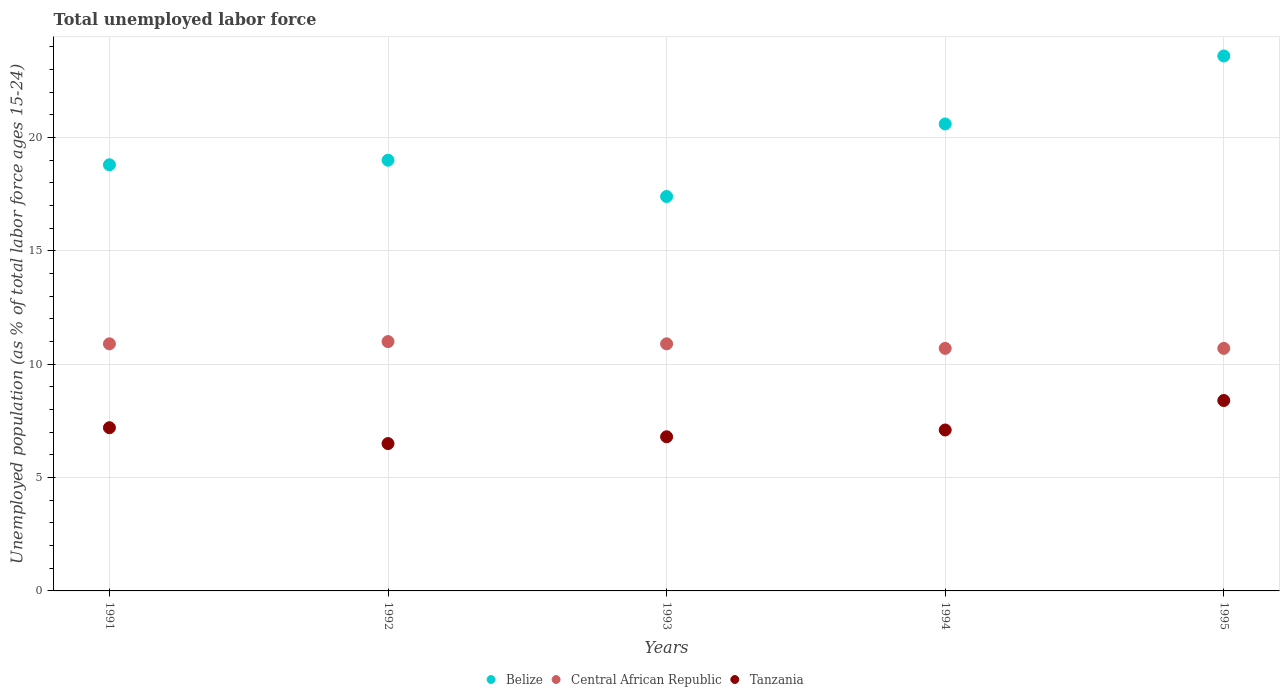Is the number of dotlines equal to the number of legend labels?
Provide a short and direct response. Yes. What is the percentage of unemployed population in in Tanzania in 1994?
Offer a terse response. 7.1. What is the total percentage of unemployed population in in Central African Republic in the graph?
Provide a short and direct response. 54.2. What is the difference between the percentage of unemployed population in in Central African Republic in 1991 and that in 1993?
Your answer should be compact. 0. What is the difference between the percentage of unemployed population in in Belize in 1993 and the percentage of unemployed population in in Central African Republic in 1995?
Provide a short and direct response. 6.7. What is the average percentage of unemployed population in in Tanzania per year?
Provide a succinct answer. 7.2. In the year 1993, what is the difference between the percentage of unemployed population in in Central African Republic and percentage of unemployed population in in Tanzania?
Provide a short and direct response. 4.1. What is the ratio of the percentage of unemployed population in in Belize in 1992 to that in 1995?
Provide a short and direct response. 0.81. Is the difference between the percentage of unemployed population in in Central African Republic in 1991 and 1993 greater than the difference between the percentage of unemployed population in in Tanzania in 1991 and 1993?
Make the answer very short. No. What is the difference between the highest and the second highest percentage of unemployed population in in Tanzania?
Your response must be concise. 1.2. What is the difference between the highest and the lowest percentage of unemployed population in in Central African Republic?
Make the answer very short. 0.3. Does the percentage of unemployed population in in Belize monotonically increase over the years?
Your answer should be compact. No. Is the percentage of unemployed population in in Tanzania strictly less than the percentage of unemployed population in in Central African Republic over the years?
Your response must be concise. Yes. What is the difference between two consecutive major ticks on the Y-axis?
Provide a short and direct response. 5. Are the values on the major ticks of Y-axis written in scientific E-notation?
Offer a terse response. No. Does the graph contain grids?
Your answer should be very brief. Yes. Where does the legend appear in the graph?
Your answer should be compact. Bottom center. How many legend labels are there?
Offer a terse response. 3. How are the legend labels stacked?
Give a very brief answer. Horizontal. What is the title of the graph?
Make the answer very short. Total unemployed labor force. Does "Northern Mariana Islands" appear as one of the legend labels in the graph?
Provide a succinct answer. No. What is the label or title of the X-axis?
Offer a very short reply. Years. What is the label or title of the Y-axis?
Offer a terse response. Unemployed population (as % of total labor force ages 15-24). What is the Unemployed population (as % of total labor force ages 15-24) in Belize in 1991?
Your response must be concise. 18.8. What is the Unemployed population (as % of total labor force ages 15-24) in Central African Republic in 1991?
Ensure brevity in your answer.  10.9. What is the Unemployed population (as % of total labor force ages 15-24) of Tanzania in 1991?
Your response must be concise. 7.2. What is the Unemployed population (as % of total labor force ages 15-24) in Belize in 1993?
Ensure brevity in your answer.  17.4. What is the Unemployed population (as % of total labor force ages 15-24) of Central African Republic in 1993?
Your response must be concise. 10.9. What is the Unemployed population (as % of total labor force ages 15-24) of Tanzania in 1993?
Your answer should be very brief. 6.8. What is the Unemployed population (as % of total labor force ages 15-24) in Belize in 1994?
Provide a succinct answer. 20.6. What is the Unemployed population (as % of total labor force ages 15-24) of Central African Republic in 1994?
Your answer should be compact. 10.7. What is the Unemployed population (as % of total labor force ages 15-24) of Tanzania in 1994?
Offer a terse response. 7.1. What is the Unemployed population (as % of total labor force ages 15-24) of Belize in 1995?
Provide a short and direct response. 23.6. What is the Unemployed population (as % of total labor force ages 15-24) of Central African Republic in 1995?
Keep it short and to the point. 10.7. What is the Unemployed population (as % of total labor force ages 15-24) in Tanzania in 1995?
Ensure brevity in your answer.  8.4. Across all years, what is the maximum Unemployed population (as % of total labor force ages 15-24) in Belize?
Your answer should be compact. 23.6. Across all years, what is the maximum Unemployed population (as % of total labor force ages 15-24) in Tanzania?
Make the answer very short. 8.4. Across all years, what is the minimum Unemployed population (as % of total labor force ages 15-24) of Belize?
Ensure brevity in your answer.  17.4. Across all years, what is the minimum Unemployed population (as % of total labor force ages 15-24) of Central African Republic?
Your answer should be very brief. 10.7. Across all years, what is the minimum Unemployed population (as % of total labor force ages 15-24) of Tanzania?
Your answer should be compact. 6.5. What is the total Unemployed population (as % of total labor force ages 15-24) of Belize in the graph?
Provide a short and direct response. 99.4. What is the total Unemployed population (as % of total labor force ages 15-24) of Central African Republic in the graph?
Ensure brevity in your answer.  54.2. What is the total Unemployed population (as % of total labor force ages 15-24) of Tanzania in the graph?
Your answer should be very brief. 36. What is the difference between the Unemployed population (as % of total labor force ages 15-24) in Belize in 1991 and that in 1992?
Your answer should be compact. -0.2. What is the difference between the Unemployed population (as % of total labor force ages 15-24) in Central African Republic in 1991 and that in 1993?
Provide a succinct answer. 0. What is the difference between the Unemployed population (as % of total labor force ages 15-24) in Tanzania in 1991 and that in 1994?
Offer a very short reply. 0.1. What is the difference between the Unemployed population (as % of total labor force ages 15-24) of Central African Republic in 1991 and that in 1995?
Your response must be concise. 0.2. What is the difference between the Unemployed population (as % of total labor force ages 15-24) in Tanzania in 1991 and that in 1995?
Offer a terse response. -1.2. What is the difference between the Unemployed population (as % of total labor force ages 15-24) in Central African Republic in 1992 and that in 1993?
Provide a succinct answer. 0.1. What is the difference between the Unemployed population (as % of total labor force ages 15-24) of Tanzania in 1992 and that in 1993?
Provide a succinct answer. -0.3. What is the difference between the Unemployed population (as % of total labor force ages 15-24) of Belize in 1992 and that in 1994?
Keep it short and to the point. -1.6. What is the difference between the Unemployed population (as % of total labor force ages 15-24) in Central African Republic in 1992 and that in 1994?
Give a very brief answer. 0.3. What is the difference between the Unemployed population (as % of total labor force ages 15-24) of Tanzania in 1992 and that in 1994?
Make the answer very short. -0.6. What is the difference between the Unemployed population (as % of total labor force ages 15-24) in Central African Republic in 1992 and that in 1995?
Offer a terse response. 0.3. What is the difference between the Unemployed population (as % of total labor force ages 15-24) in Tanzania in 1992 and that in 1995?
Provide a succinct answer. -1.9. What is the difference between the Unemployed population (as % of total labor force ages 15-24) of Belize in 1993 and that in 1994?
Your answer should be very brief. -3.2. What is the difference between the Unemployed population (as % of total labor force ages 15-24) in Central African Republic in 1993 and that in 1994?
Ensure brevity in your answer.  0.2. What is the difference between the Unemployed population (as % of total labor force ages 15-24) of Tanzania in 1993 and that in 1994?
Give a very brief answer. -0.3. What is the difference between the Unemployed population (as % of total labor force ages 15-24) in Central African Republic in 1993 and that in 1995?
Offer a very short reply. 0.2. What is the difference between the Unemployed population (as % of total labor force ages 15-24) in Tanzania in 1993 and that in 1995?
Your answer should be very brief. -1.6. What is the difference between the Unemployed population (as % of total labor force ages 15-24) in Central African Republic in 1994 and that in 1995?
Your answer should be very brief. 0. What is the difference between the Unemployed population (as % of total labor force ages 15-24) of Tanzania in 1994 and that in 1995?
Make the answer very short. -1.3. What is the difference between the Unemployed population (as % of total labor force ages 15-24) of Central African Republic in 1991 and the Unemployed population (as % of total labor force ages 15-24) of Tanzania in 1992?
Your answer should be compact. 4.4. What is the difference between the Unemployed population (as % of total labor force ages 15-24) of Belize in 1991 and the Unemployed population (as % of total labor force ages 15-24) of Tanzania in 1994?
Your response must be concise. 11.7. What is the difference between the Unemployed population (as % of total labor force ages 15-24) of Central African Republic in 1991 and the Unemployed population (as % of total labor force ages 15-24) of Tanzania in 1994?
Offer a terse response. 3.8. What is the difference between the Unemployed population (as % of total labor force ages 15-24) of Belize in 1991 and the Unemployed population (as % of total labor force ages 15-24) of Tanzania in 1995?
Your answer should be very brief. 10.4. What is the difference between the Unemployed population (as % of total labor force ages 15-24) of Central African Republic in 1991 and the Unemployed population (as % of total labor force ages 15-24) of Tanzania in 1995?
Keep it short and to the point. 2.5. What is the difference between the Unemployed population (as % of total labor force ages 15-24) of Belize in 1992 and the Unemployed population (as % of total labor force ages 15-24) of Tanzania in 1993?
Make the answer very short. 12.2. What is the difference between the Unemployed population (as % of total labor force ages 15-24) in Belize in 1992 and the Unemployed population (as % of total labor force ages 15-24) in Central African Republic in 1994?
Give a very brief answer. 8.3. What is the difference between the Unemployed population (as % of total labor force ages 15-24) in Belize in 1992 and the Unemployed population (as % of total labor force ages 15-24) in Tanzania in 1994?
Provide a short and direct response. 11.9. What is the difference between the Unemployed population (as % of total labor force ages 15-24) in Belize in 1993 and the Unemployed population (as % of total labor force ages 15-24) in Tanzania in 1994?
Give a very brief answer. 10.3. What is the difference between the Unemployed population (as % of total labor force ages 15-24) of Central African Republic in 1993 and the Unemployed population (as % of total labor force ages 15-24) of Tanzania in 1994?
Offer a terse response. 3.8. What is the difference between the Unemployed population (as % of total labor force ages 15-24) of Belize in 1993 and the Unemployed population (as % of total labor force ages 15-24) of Tanzania in 1995?
Make the answer very short. 9. What is the difference between the Unemployed population (as % of total labor force ages 15-24) of Belize in 1994 and the Unemployed population (as % of total labor force ages 15-24) of Central African Republic in 1995?
Provide a succinct answer. 9.9. What is the difference between the Unemployed population (as % of total labor force ages 15-24) in Belize in 1994 and the Unemployed population (as % of total labor force ages 15-24) in Tanzania in 1995?
Give a very brief answer. 12.2. What is the average Unemployed population (as % of total labor force ages 15-24) in Belize per year?
Keep it short and to the point. 19.88. What is the average Unemployed population (as % of total labor force ages 15-24) of Central African Republic per year?
Keep it short and to the point. 10.84. What is the average Unemployed population (as % of total labor force ages 15-24) of Tanzania per year?
Provide a succinct answer. 7.2. In the year 1991, what is the difference between the Unemployed population (as % of total labor force ages 15-24) of Belize and Unemployed population (as % of total labor force ages 15-24) of Central African Republic?
Offer a very short reply. 7.9. In the year 1992, what is the difference between the Unemployed population (as % of total labor force ages 15-24) of Belize and Unemployed population (as % of total labor force ages 15-24) of Tanzania?
Offer a terse response. 12.5. In the year 1992, what is the difference between the Unemployed population (as % of total labor force ages 15-24) in Central African Republic and Unemployed population (as % of total labor force ages 15-24) in Tanzania?
Your answer should be compact. 4.5. In the year 1994, what is the difference between the Unemployed population (as % of total labor force ages 15-24) of Belize and Unemployed population (as % of total labor force ages 15-24) of Central African Republic?
Your response must be concise. 9.9. In the year 1995, what is the difference between the Unemployed population (as % of total labor force ages 15-24) in Belize and Unemployed population (as % of total labor force ages 15-24) in Central African Republic?
Keep it short and to the point. 12.9. In the year 1995, what is the difference between the Unemployed population (as % of total labor force ages 15-24) in Central African Republic and Unemployed population (as % of total labor force ages 15-24) in Tanzania?
Ensure brevity in your answer.  2.3. What is the ratio of the Unemployed population (as % of total labor force ages 15-24) in Central African Republic in 1991 to that in 1992?
Provide a short and direct response. 0.99. What is the ratio of the Unemployed population (as % of total labor force ages 15-24) of Tanzania in 1991 to that in 1992?
Keep it short and to the point. 1.11. What is the ratio of the Unemployed population (as % of total labor force ages 15-24) of Belize in 1991 to that in 1993?
Provide a short and direct response. 1.08. What is the ratio of the Unemployed population (as % of total labor force ages 15-24) in Central African Republic in 1991 to that in 1993?
Your answer should be compact. 1. What is the ratio of the Unemployed population (as % of total labor force ages 15-24) of Tanzania in 1991 to that in 1993?
Keep it short and to the point. 1.06. What is the ratio of the Unemployed population (as % of total labor force ages 15-24) in Belize in 1991 to that in 1994?
Your answer should be very brief. 0.91. What is the ratio of the Unemployed population (as % of total labor force ages 15-24) in Central African Republic in 1991 to that in 1994?
Offer a very short reply. 1.02. What is the ratio of the Unemployed population (as % of total labor force ages 15-24) of Tanzania in 1991 to that in 1994?
Provide a succinct answer. 1.01. What is the ratio of the Unemployed population (as % of total labor force ages 15-24) in Belize in 1991 to that in 1995?
Ensure brevity in your answer.  0.8. What is the ratio of the Unemployed population (as % of total labor force ages 15-24) in Central African Republic in 1991 to that in 1995?
Give a very brief answer. 1.02. What is the ratio of the Unemployed population (as % of total labor force ages 15-24) of Belize in 1992 to that in 1993?
Your answer should be very brief. 1.09. What is the ratio of the Unemployed population (as % of total labor force ages 15-24) of Central African Republic in 1992 to that in 1993?
Offer a very short reply. 1.01. What is the ratio of the Unemployed population (as % of total labor force ages 15-24) of Tanzania in 1992 to that in 1993?
Give a very brief answer. 0.96. What is the ratio of the Unemployed population (as % of total labor force ages 15-24) of Belize in 1992 to that in 1994?
Make the answer very short. 0.92. What is the ratio of the Unemployed population (as % of total labor force ages 15-24) in Central African Republic in 1992 to that in 1994?
Your response must be concise. 1.03. What is the ratio of the Unemployed population (as % of total labor force ages 15-24) in Tanzania in 1992 to that in 1994?
Give a very brief answer. 0.92. What is the ratio of the Unemployed population (as % of total labor force ages 15-24) in Belize in 1992 to that in 1995?
Provide a succinct answer. 0.81. What is the ratio of the Unemployed population (as % of total labor force ages 15-24) in Central African Republic in 1992 to that in 1995?
Your answer should be very brief. 1.03. What is the ratio of the Unemployed population (as % of total labor force ages 15-24) of Tanzania in 1992 to that in 1995?
Your response must be concise. 0.77. What is the ratio of the Unemployed population (as % of total labor force ages 15-24) of Belize in 1993 to that in 1994?
Offer a very short reply. 0.84. What is the ratio of the Unemployed population (as % of total labor force ages 15-24) of Central African Republic in 1993 to that in 1994?
Offer a terse response. 1.02. What is the ratio of the Unemployed population (as % of total labor force ages 15-24) of Tanzania in 1993 to that in 1994?
Make the answer very short. 0.96. What is the ratio of the Unemployed population (as % of total labor force ages 15-24) of Belize in 1993 to that in 1995?
Provide a succinct answer. 0.74. What is the ratio of the Unemployed population (as % of total labor force ages 15-24) in Central African Republic in 1993 to that in 1995?
Ensure brevity in your answer.  1.02. What is the ratio of the Unemployed population (as % of total labor force ages 15-24) in Tanzania in 1993 to that in 1995?
Ensure brevity in your answer.  0.81. What is the ratio of the Unemployed population (as % of total labor force ages 15-24) in Belize in 1994 to that in 1995?
Your response must be concise. 0.87. What is the ratio of the Unemployed population (as % of total labor force ages 15-24) of Central African Republic in 1994 to that in 1995?
Keep it short and to the point. 1. What is the ratio of the Unemployed population (as % of total labor force ages 15-24) in Tanzania in 1994 to that in 1995?
Ensure brevity in your answer.  0.85. What is the difference between the highest and the second highest Unemployed population (as % of total labor force ages 15-24) in Central African Republic?
Make the answer very short. 0.1. What is the difference between the highest and the second highest Unemployed population (as % of total labor force ages 15-24) of Tanzania?
Offer a very short reply. 1.2. What is the difference between the highest and the lowest Unemployed population (as % of total labor force ages 15-24) of Belize?
Your response must be concise. 6.2. What is the difference between the highest and the lowest Unemployed population (as % of total labor force ages 15-24) of Central African Republic?
Your response must be concise. 0.3. 